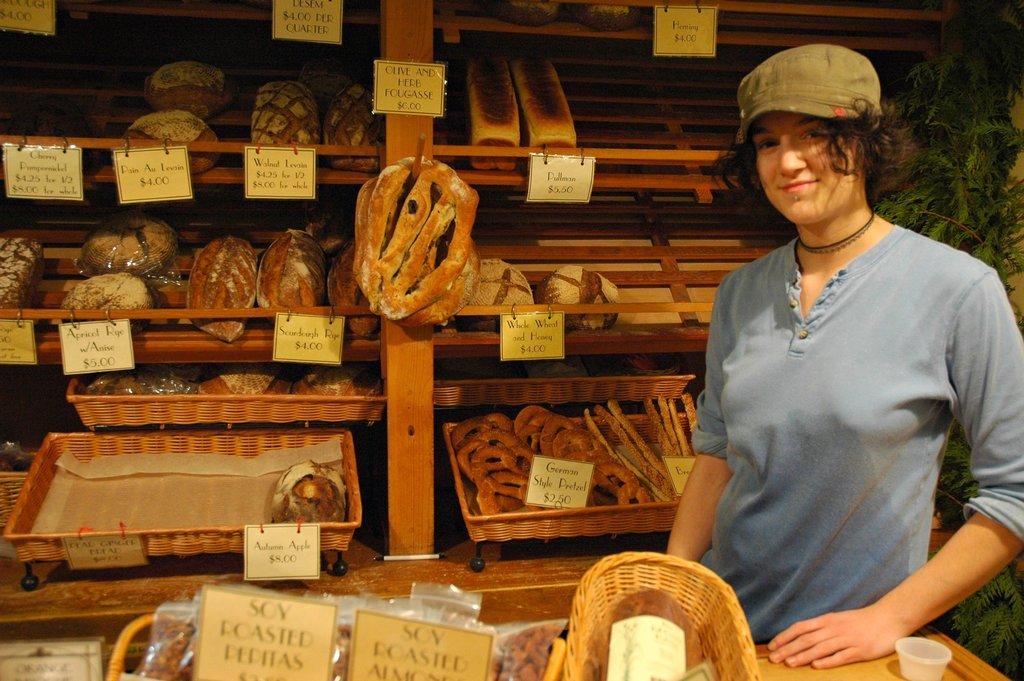What kind of pepitas are those?
Offer a terse response. Soy roasted. How much are the pretzels?
Your response must be concise. 2.50. 